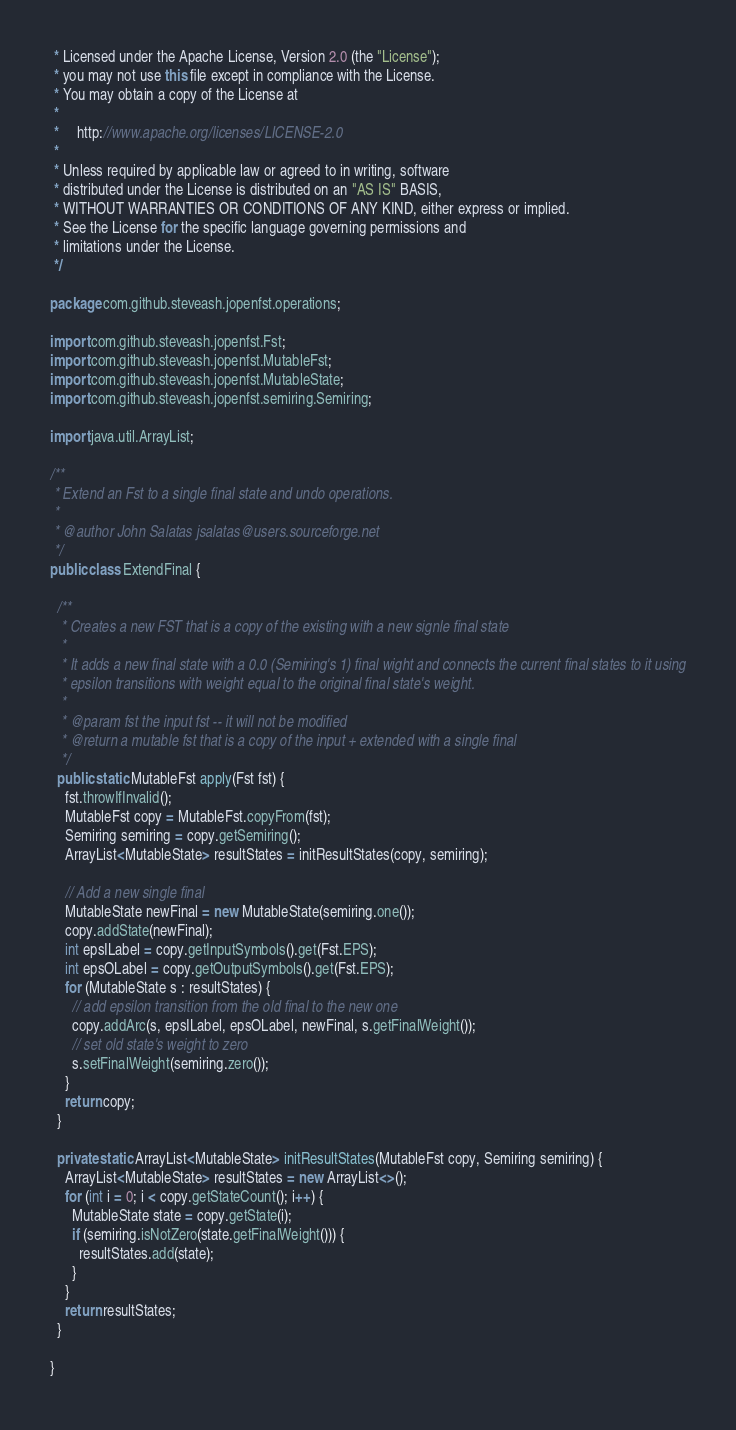Convert code to text. <code><loc_0><loc_0><loc_500><loc_500><_Java_> * Licensed under the Apache License, Version 2.0 (the "License");
 * you may not use this file except in compliance with the License.
 * You may obtain a copy of the License at
 *
 *     http://www.apache.org/licenses/LICENSE-2.0
 *
 * Unless required by applicable law or agreed to in writing, software
 * distributed under the License is distributed on an "AS IS" BASIS,
 * WITHOUT WARRANTIES OR CONDITIONS OF ANY KIND, either express or implied.
 * See the License for the specific language governing permissions and
 * limitations under the License.
 */

package com.github.steveash.jopenfst.operations;

import com.github.steveash.jopenfst.Fst;
import com.github.steveash.jopenfst.MutableFst;
import com.github.steveash.jopenfst.MutableState;
import com.github.steveash.jopenfst.semiring.Semiring;

import java.util.ArrayList;

/**
 * Extend an Fst to a single final state and undo operations.
 *
 * @author John Salatas jsalatas@users.sourceforge.net
 */
public class ExtendFinal {

  /**
   * Creates a new FST that is a copy of the existing with a new signle final state
   *
   * It adds a new final state with a 0.0 (Semiring's 1) final wight and connects the current final states to it using
   * epsilon transitions with weight equal to the original final state's weight.
   *
   * @param fst the input fst -- it will not be modified
   * @return a mutable fst that is a copy of the input + extended with a single final
   */
  public static MutableFst apply(Fst fst) {
    fst.throwIfInvalid();
    MutableFst copy = MutableFst.copyFrom(fst);
    Semiring semiring = copy.getSemiring();
    ArrayList<MutableState> resultStates = initResultStates(copy, semiring);

    // Add a new single final
    MutableState newFinal = new MutableState(semiring.one());
    copy.addState(newFinal);
    int epsILabel = copy.getInputSymbols().get(Fst.EPS);
    int epsOLabel = copy.getOutputSymbols().get(Fst.EPS);
    for (MutableState s : resultStates) {
      // add epsilon transition from the old final to the new one
      copy.addArc(s, epsILabel, epsOLabel, newFinal, s.getFinalWeight());
      // set old state's weight to zero
      s.setFinalWeight(semiring.zero());
    }
    return copy;
  }

  private static ArrayList<MutableState> initResultStates(MutableFst copy, Semiring semiring) {
    ArrayList<MutableState> resultStates = new ArrayList<>();
    for (int i = 0; i < copy.getStateCount(); i++) {
      MutableState state = copy.getState(i);
      if (semiring.isNotZero(state.getFinalWeight())) {
        resultStates.add(state);
      }
    }
    return resultStates;
  }

}
</code> 